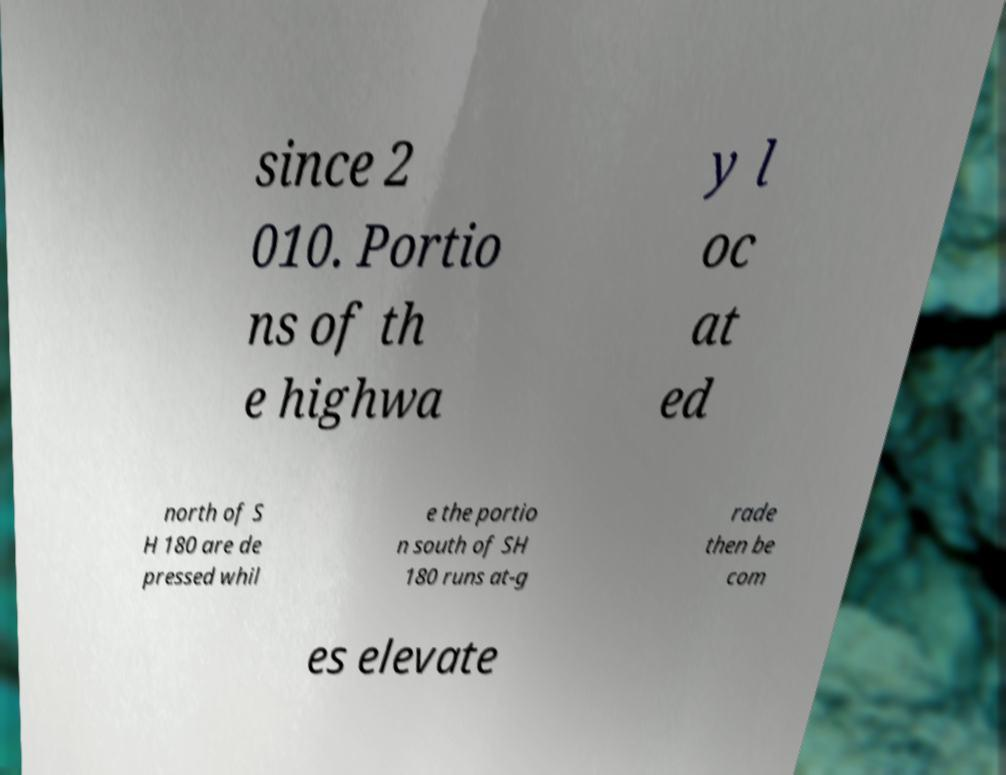Can you accurately transcribe the text from the provided image for me? since 2 010. Portio ns of th e highwa y l oc at ed north of S H 180 are de pressed whil e the portio n south of SH 180 runs at-g rade then be com es elevate 